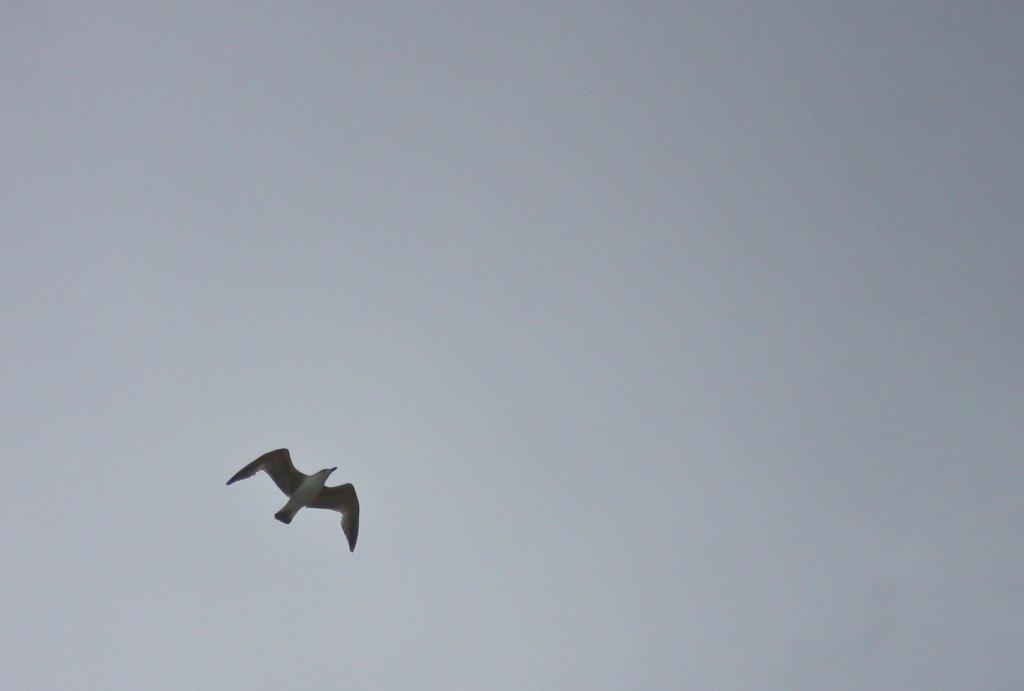Can you describe this image briefly? In this image we can see a bird flying and in the background, we can see the sky. 